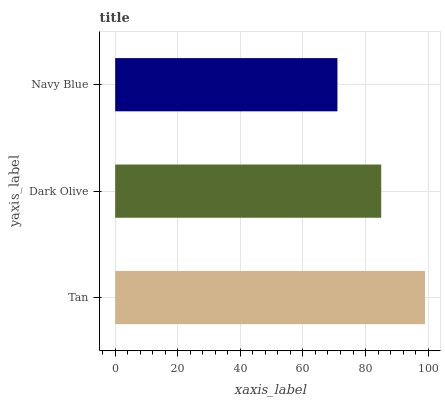Is Navy Blue the minimum?
Answer yes or no. Yes. Is Tan the maximum?
Answer yes or no. Yes. Is Dark Olive the minimum?
Answer yes or no. No. Is Dark Olive the maximum?
Answer yes or no. No. Is Tan greater than Dark Olive?
Answer yes or no. Yes. Is Dark Olive less than Tan?
Answer yes or no. Yes. Is Dark Olive greater than Tan?
Answer yes or no. No. Is Tan less than Dark Olive?
Answer yes or no. No. Is Dark Olive the high median?
Answer yes or no. Yes. Is Dark Olive the low median?
Answer yes or no. Yes. Is Navy Blue the high median?
Answer yes or no. No. Is Tan the low median?
Answer yes or no. No. 